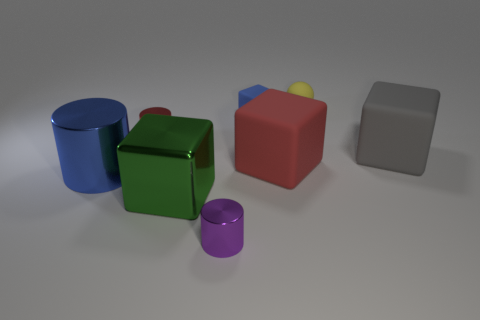How do the lighting and shadows contribute to the image's aesthetic? The lighting in the image casts soft shadows behind each object, giving a sense of depth and dimension. It also highlights the textures and the true colors of the objects. The subtle reflections on the surfaces suggest the objects are placed in a three-dimensional space, enhancing the visual appeal and realism of the scene. 